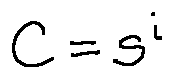<formula> <loc_0><loc_0><loc_500><loc_500>C = s ^ { i }</formula> 